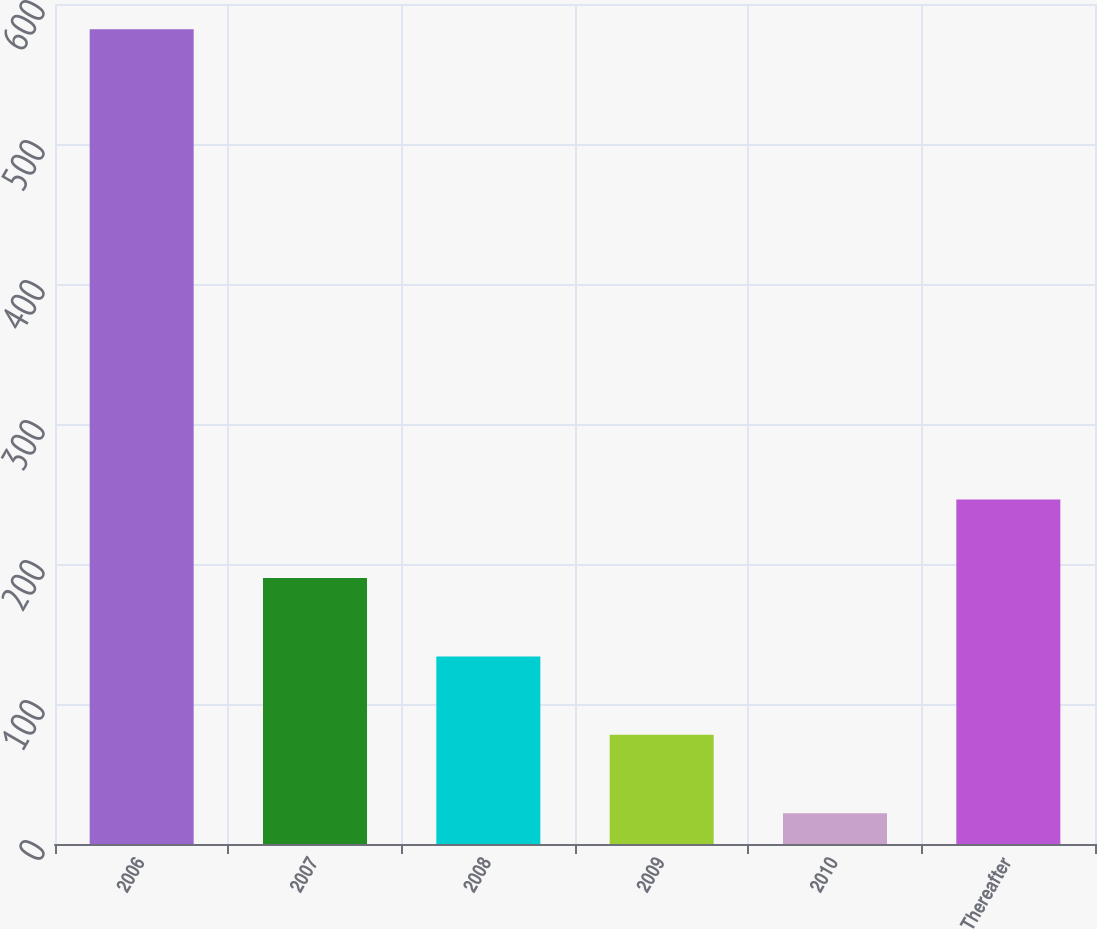Convert chart. <chart><loc_0><loc_0><loc_500><loc_500><bar_chart><fcel>2006<fcel>2007<fcel>2008<fcel>2009<fcel>2010<fcel>Thereafter<nl><fcel>582<fcel>190<fcel>134<fcel>78<fcel>22<fcel>246<nl></chart> 